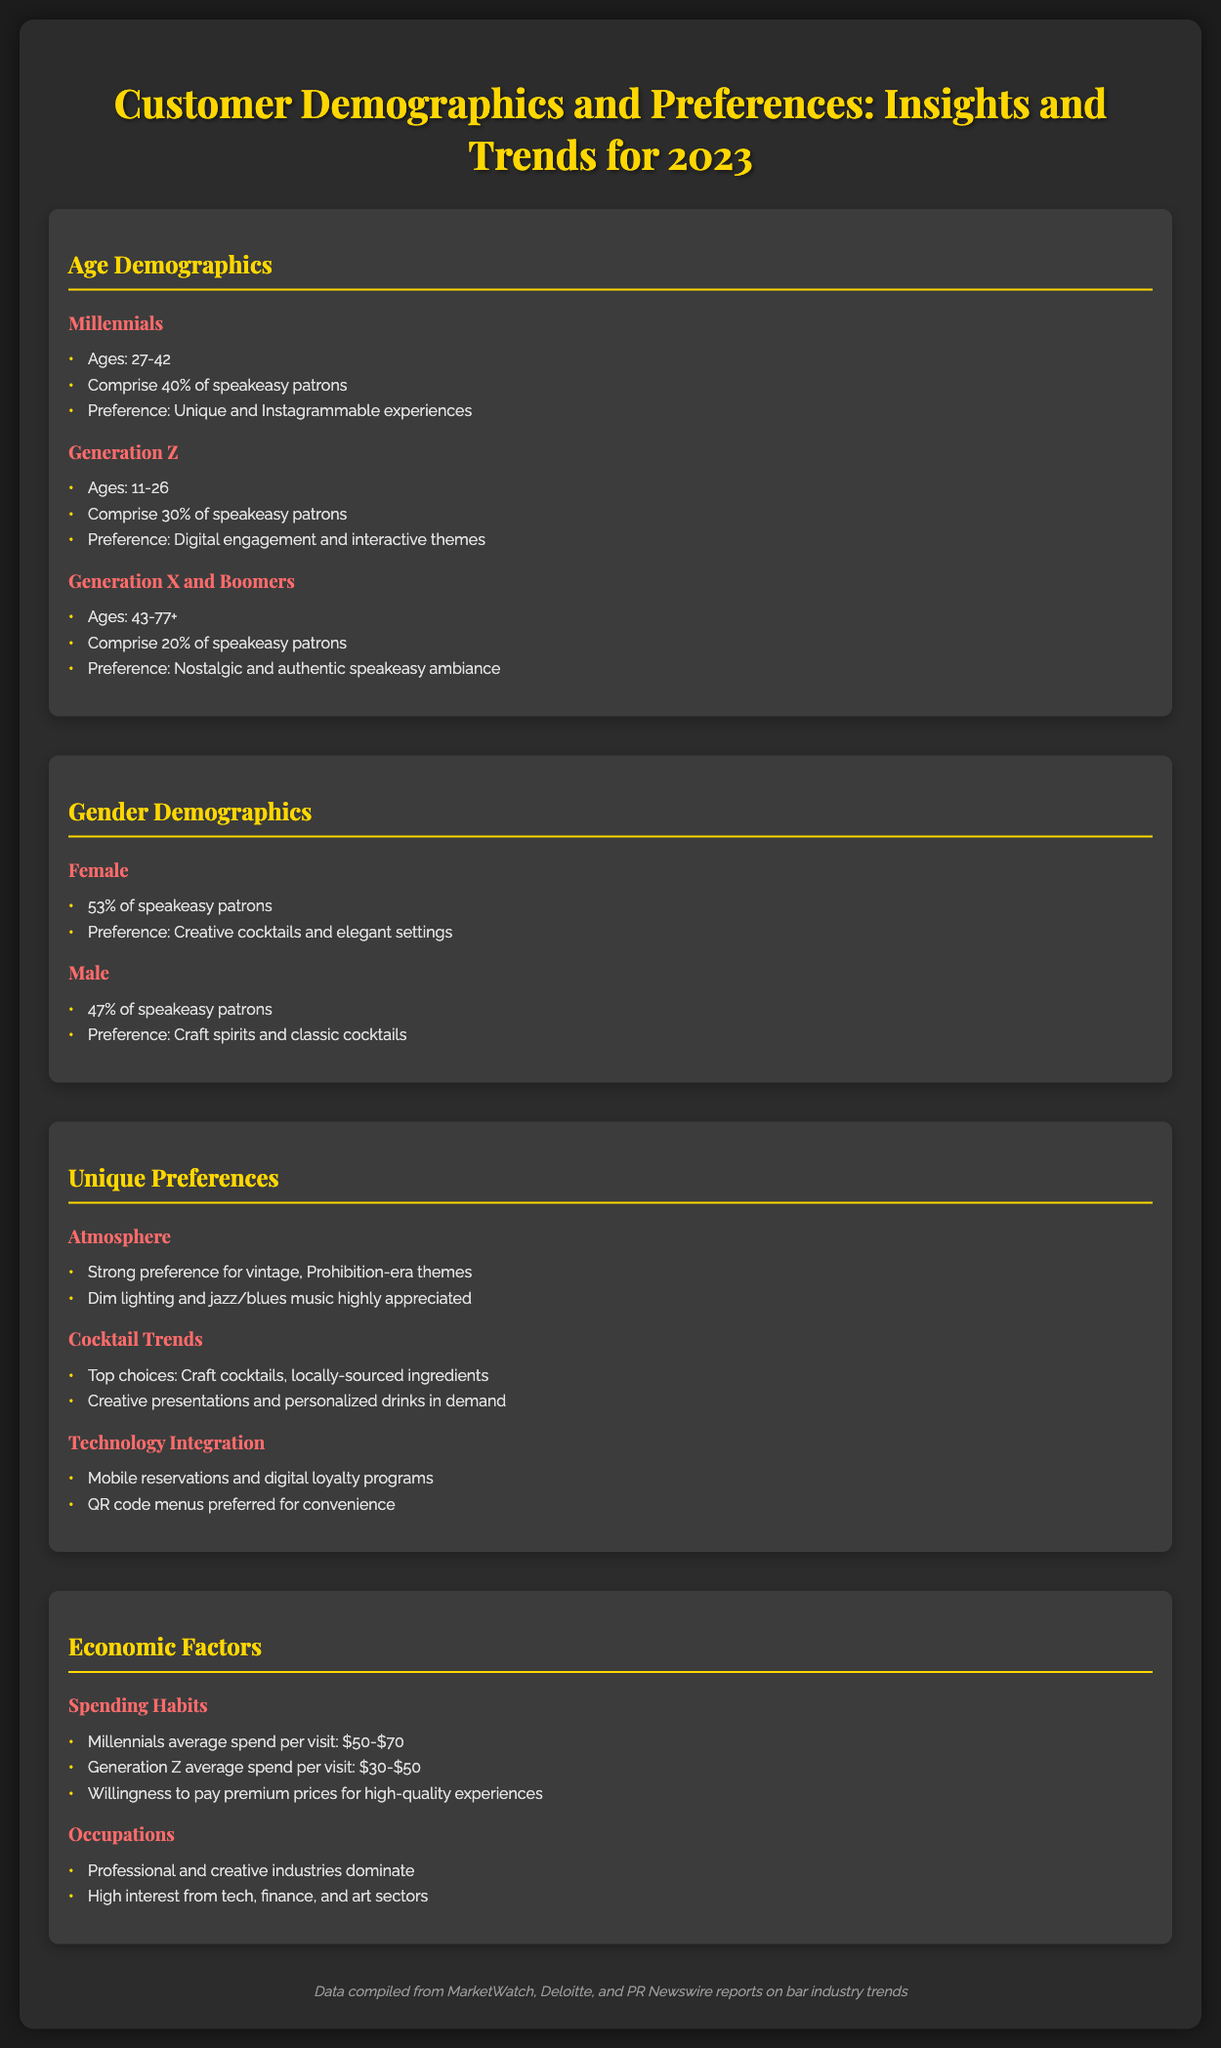what percentage of speakeasy patrons are Millennials? The document states that Millennials comprise 40% of speakeasy patrons.
Answer: 40% what is the average spend per visit for Generation Z? The document specifies that Generation Z has an average spend per visit of $30-$50.
Answer: $30-$50 what type of cocktails do female patrons prefer? The document mentions that female patrons prefer creative cocktails and elegant settings.
Answer: Creative cocktails what is the age range of Generation X and Boomers? The document indicates that Generation X and Boomers are aged 43-77+.
Answer: 43-77+ what atmosphere is preferred by speakeasy patrons? The document highlights a strong preference for vintage, Prohibition-era themes.
Answer: Vintage, Prohibition-era themes what percentage of speakeasy patrons are female? The document states that 53% of speakeasy patrons are female.
Answer: 53% what technology integration is preferred for convenience? The document notes that QR code menus are preferred for convenience.
Answer: QR code menus what industries dominate the occupations of speakeasy patrons? The document indicates that professional and creative industries dominate.
Answer: Professional and creative industries which music genre is highly appreciated in speakeasies? The document mentions that jazz/blues music is highly appreciated.
Answer: Jazz/blues music 